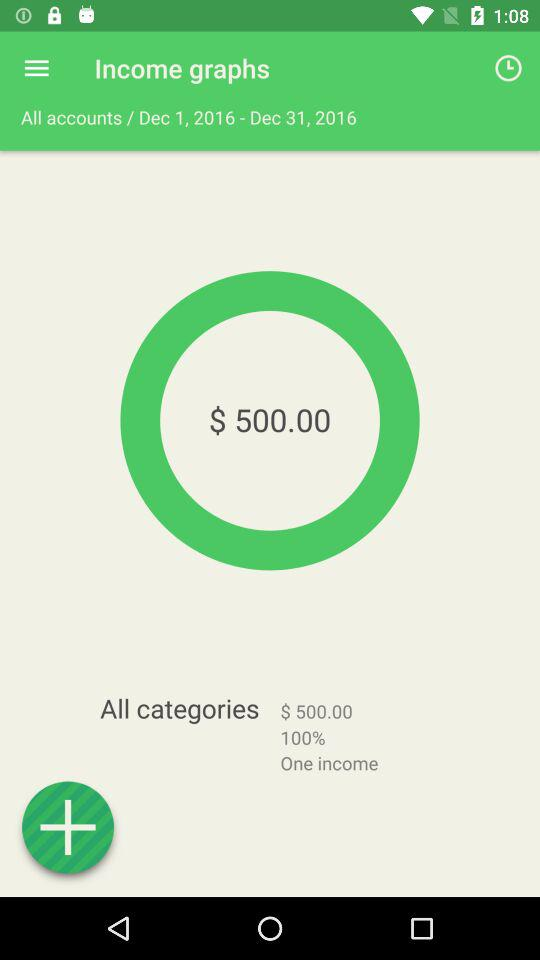What is the currency of the income earned? The currency of the income earned is dollars. 